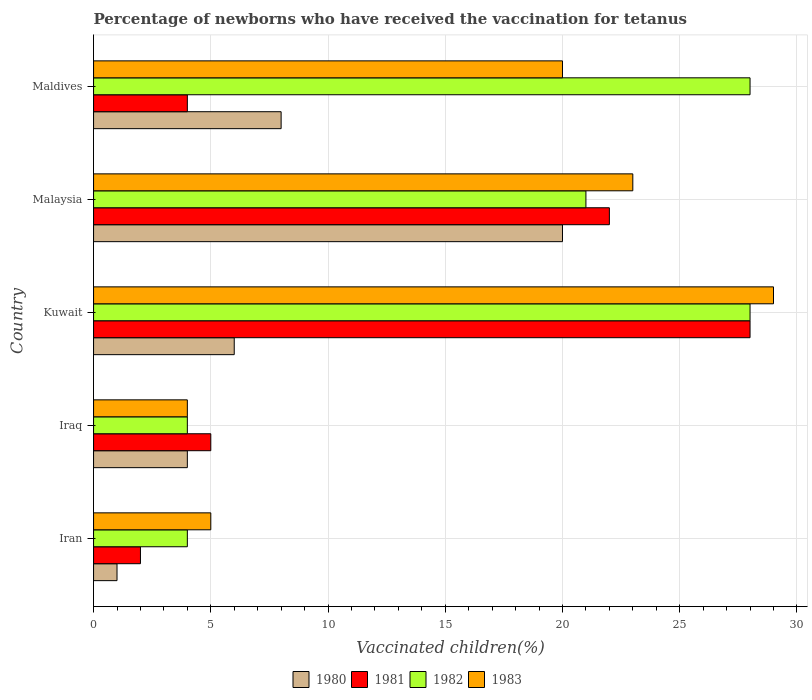How many bars are there on the 4th tick from the top?
Ensure brevity in your answer.  4. How many bars are there on the 4th tick from the bottom?
Ensure brevity in your answer.  4. What is the label of the 1st group of bars from the top?
Make the answer very short. Maldives. In how many cases, is the number of bars for a given country not equal to the number of legend labels?
Your answer should be very brief. 0. In which country was the percentage of vaccinated children in 1982 maximum?
Give a very brief answer. Kuwait. In which country was the percentage of vaccinated children in 1983 minimum?
Make the answer very short. Iraq. What is the difference between the percentage of vaccinated children in 1983 in Iran and that in Iraq?
Offer a very short reply. 1. What is the difference between the percentage of vaccinated children in 1982 in Iran and the percentage of vaccinated children in 1980 in Iraq?
Your answer should be compact. 0. What is the average percentage of vaccinated children in 1980 per country?
Provide a succinct answer. 7.8. In how many countries, is the percentage of vaccinated children in 1980 greater than 9 %?
Your answer should be very brief. 1. What is the ratio of the percentage of vaccinated children in 1982 in Iran to that in Kuwait?
Provide a short and direct response. 0.14. Is the difference between the percentage of vaccinated children in 1983 in Iraq and Maldives greater than the difference between the percentage of vaccinated children in 1982 in Iraq and Maldives?
Provide a short and direct response. Yes. What is the difference between the highest and the second highest percentage of vaccinated children in 1981?
Give a very brief answer. 6. What is the difference between the highest and the lowest percentage of vaccinated children in 1982?
Provide a short and direct response. 24. In how many countries, is the percentage of vaccinated children in 1983 greater than the average percentage of vaccinated children in 1983 taken over all countries?
Offer a terse response. 3. Is the sum of the percentage of vaccinated children in 1983 in Iran and Iraq greater than the maximum percentage of vaccinated children in 1980 across all countries?
Offer a terse response. No. What does the 3rd bar from the top in Malaysia represents?
Your answer should be compact. 1981. What does the 2nd bar from the bottom in Iran represents?
Offer a terse response. 1981. Is it the case that in every country, the sum of the percentage of vaccinated children in 1983 and percentage of vaccinated children in 1982 is greater than the percentage of vaccinated children in 1980?
Make the answer very short. Yes. How many bars are there?
Offer a very short reply. 20. Are all the bars in the graph horizontal?
Offer a terse response. Yes. Where does the legend appear in the graph?
Make the answer very short. Bottom center. How are the legend labels stacked?
Give a very brief answer. Horizontal. What is the title of the graph?
Your answer should be compact. Percentage of newborns who have received the vaccination for tetanus. What is the label or title of the X-axis?
Provide a succinct answer. Vaccinated children(%). What is the Vaccinated children(%) in 1980 in Iran?
Offer a very short reply. 1. What is the Vaccinated children(%) in 1980 in Iraq?
Your answer should be compact. 4. What is the Vaccinated children(%) in 1981 in Iraq?
Your response must be concise. 5. What is the Vaccinated children(%) of 1982 in Iraq?
Make the answer very short. 4. What is the Vaccinated children(%) of 1983 in Iraq?
Offer a very short reply. 4. What is the Vaccinated children(%) in 1980 in Kuwait?
Give a very brief answer. 6. What is the Vaccinated children(%) of 1981 in Kuwait?
Offer a very short reply. 28. What is the Vaccinated children(%) in 1983 in Kuwait?
Offer a terse response. 29. What is the Vaccinated children(%) in 1980 in Malaysia?
Your answer should be compact. 20. What is the Vaccinated children(%) in 1981 in Malaysia?
Provide a succinct answer. 22. What is the Vaccinated children(%) in 1983 in Malaysia?
Make the answer very short. 23. What is the Vaccinated children(%) in 1980 in Maldives?
Give a very brief answer. 8. What is the Vaccinated children(%) of 1983 in Maldives?
Ensure brevity in your answer.  20. Across all countries, what is the maximum Vaccinated children(%) in 1980?
Your response must be concise. 20. Across all countries, what is the minimum Vaccinated children(%) in 1982?
Ensure brevity in your answer.  4. What is the total Vaccinated children(%) of 1980 in the graph?
Your answer should be very brief. 39. What is the total Vaccinated children(%) of 1982 in the graph?
Ensure brevity in your answer.  85. What is the difference between the Vaccinated children(%) of 1980 in Iran and that in Iraq?
Your answer should be compact. -3. What is the difference between the Vaccinated children(%) in 1981 in Iran and that in Iraq?
Your answer should be very brief. -3. What is the difference between the Vaccinated children(%) in 1982 in Iran and that in Kuwait?
Keep it short and to the point. -24. What is the difference between the Vaccinated children(%) of 1983 in Iran and that in Malaysia?
Your answer should be very brief. -18. What is the difference between the Vaccinated children(%) in 1982 in Iraq and that in Kuwait?
Your response must be concise. -24. What is the difference between the Vaccinated children(%) in 1981 in Iraq and that in Malaysia?
Ensure brevity in your answer.  -17. What is the difference between the Vaccinated children(%) of 1982 in Iraq and that in Malaysia?
Your answer should be very brief. -17. What is the difference between the Vaccinated children(%) of 1983 in Iraq and that in Malaysia?
Offer a very short reply. -19. What is the difference between the Vaccinated children(%) of 1980 in Iraq and that in Maldives?
Your answer should be very brief. -4. What is the difference between the Vaccinated children(%) of 1981 in Iraq and that in Maldives?
Give a very brief answer. 1. What is the difference between the Vaccinated children(%) in 1982 in Iraq and that in Maldives?
Give a very brief answer. -24. What is the difference between the Vaccinated children(%) of 1980 in Kuwait and that in Malaysia?
Make the answer very short. -14. What is the difference between the Vaccinated children(%) in 1981 in Kuwait and that in Malaysia?
Offer a very short reply. 6. What is the difference between the Vaccinated children(%) of 1983 in Kuwait and that in Maldives?
Ensure brevity in your answer.  9. What is the difference between the Vaccinated children(%) of 1980 in Malaysia and that in Maldives?
Ensure brevity in your answer.  12. What is the difference between the Vaccinated children(%) in 1980 in Iran and the Vaccinated children(%) in 1982 in Iraq?
Your answer should be compact. -3. What is the difference between the Vaccinated children(%) of 1980 in Iran and the Vaccinated children(%) of 1983 in Iraq?
Give a very brief answer. -3. What is the difference between the Vaccinated children(%) in 1981 in Iran and the Vaccinated children(%) in 1983 in Iraq?
Ensure brevity in your answer.  -2. What is the difference between the Vaccinated children(%) of 1982 in Iran and the Vaccinated children(%) of 1983 in Iraq?
Provide a short and direct response. 0. What is the difference between the Vaccinated children(%) of 1980 in Iran and the Vaccinated children(%) of 1982 in Kuwait?
Give a very brief answer. -27. What is the difference between the Vaccinated children(%) of 1981 in Iran and the Vaccinated children(%) of 1983 in Kuwait?
Provide a succinct answer. -27. What is the difference between the Vaccinated children(%) of 1980 in Iran and the Vaccinated children(%) of 1981 in Maldives?
Provide a succinct answer. -3. What is the difference between the Vaccinated children(%) in 1980 in Iran and the Vaccinated children(%) in 1982 in Maldives?
Ensure brevity in your answer.  -27. What is the difference between the Vaccinated children(%) of 1980 in Iran and the Vaccinated children(%) of 1983 in Maldives?
Your answer should be compact. -19. What is the difference between the Vaccinated children(%) of 1981 in Iran and the Vaccinated children(%) of 1982 in Maldives?
Offer a terse response. -26. What is the difference between the Vaccinated children(%) of 1981 in Iran and the Vaccinated children(%) of 1983 in Maldives?
Provide a short and direct response. -18. What is the difference between the Vaccinated children(%) of 1982 in Iran and the Vaccinated children(%) of 1983 in Maldives?
Provide a succinct answer. -16. What is the difference between the Vaccinated children(%) in 1980 in Iraq and the Vaccinated children(%) in 1981 in Kuwait?
Offer a very short reply. -24. What is the difference between the Vaccinated children(%) in 1981 in Iraq and the Vaccinated children(%) in 1982 in Kuwait?
Keep it short and to the point. -23. What is the difference between the Vaccinated children(%) of 1980 in Iraq and the Vaccinated children(%) of 1982 in Malaysia?
Provide a succinct answer. -17. What is the difference between the Vaccinated children(%) of 1981 in Iraq and the Vaccinated children(%) of 1982 in Malaysia?
Your response must be concise. -16. What is the difference between the Vaccinated children(%) in 1982 in Iraq and the Vaccinated children(%) in 1983 in Malaysia?
Your answer should be very brief. -19. What is the difference between the Vaccinated children(%) of 1980 in Iraq and the Vaccinated children(%) of 1982 in Maldives?
Offer a terse response. -24. What is the difference between the Vaccinated children(%) of 1980 in Kuwait and the Vaccinated children(%) of 1981 in Malaysia?
Offer a very short reply. -16. What is the difference between the Vaccinated children(%) of 1980 in Kuwait and the Vaccinated children(%) of 1981 in Maldives?
Keep it short and to the point. 2. What is the difference between the Vaccinated children(%) in 1982 in Kuwait and the Vaccinated children(%) in 1983 in Maldives?
Ensure brevity in your answer.  8. What is the difference between the Vaccinated children(%) of 1980 in Malaysia and the Vaccinated children(%) of 1983 in Maldives?
Your answer should be compact. 0. What is the average Vaccinated children(%) in 1982 per country?
Your answer should be very brief. 17. What is the difference between the Vaccinated children(%) of 1980 and Vaccinated children(%) of 1983 in Iran?
Make the answer very short. -4. What is the difference between the Vaccinated children(%) in 1980 and Vaccinated children(%) in 1982 in Iraq?
Offer a terse response. 0. What is the difference between the Vaccinated children(%) of 1980 and Vaccinated children(%) of 1983 in Iraq?
Offer a very short reply. 0. What is the difference between the Vaccinated children(%) of 1981 and Vaccinated children(%) of 1983 in Iraq?
Offer a terse response. 1. What is the difference between the Vaccinated children(%) in 1982 and Vaccinated children(%) in 1983 in Iraq?
Give a very brief answer. 0. What is the difference between the Vaccinated children(%) of 1980 and Vaccinated children(%) of 1981 in Kuwait?
Ensure brevity in your answer.  -22. What is the difference between the Vaccinated children(%) of 1980 and Vaccinated children(%) of 1983 in Kuwait?
Your answer should be very brief. -23. What is the difference between the Vaccinated children(%) in 1981 and Vaccinated children(%) in 1982 in Kuwait?
Give a very brief answer. 0. What is the difference between the Vaccinated children(%) of 1980 and Vaccinated children(%) of 1983 in Malaysia?
Offer a terse response. -3. What is the difference between the Vaccinated children(%) in 1981 and Vaccinated children(%) in 1982 in Malaysia?
Give a very brief answer. 1. What is the difference between the Vaccinated children(%) in 1980 and Vaccinated children(%) in 1981 in Maldives?
Keep it short and to the point. 4. What is the difference between the Vaccinated children(%) of 1981 and Vaccinated children(%) of 1983 in Maldives?
Make the answer very short. -16. What is the difference between the Vaccinated children(%) of 1982 and Vaccinated children(%) of 1983 in Maldives?
Your answer should be very brief. 8. What is the ratio of the Vaccinated children(%) in 1980 in Iran to that in Iraq?
Provide a short and direct response. 0.25. What is the ratio of the Vaccinated children(%) of 1983 in Iran to that in Iraq?
Your answer should be compact. 1.25. What is the ratio of the Vaccinated children(%) in 1980 in Iran to that in Kuwait?
Give a very brief answer. 0.17. What is the ratio of the Vaccinated children(%) of 1981 in Iran to that in Kuwait?
Your response must be concise. 0.07. What is the ratio of the Vaccinated children(%) in 1982 in Iran to that in Kuwait?
Provide a short and direct response. 0.14. What is the ratio of the Vaccinated children(%) in 1983 in Iran to that in Kuwait?
Provide a short and direct response. 0.17. What is the ratio of the Vaccinated children(%) of 1980 in Iran to that in Malaysia?
Make the answer very short. 0.05. What is the ratio of the Vaccinated children(%) in 1981 in Iran to that in Malaysia?
Provide a succinct answer. 0.09. What is the ratio of the Vaccinated children(%) of 1982 in Iran to that in Malaysia?
Provide a succinct answer. 0.19. What is the ratio of the Vaccinated children(%) in 1983 in Iran to that in Malaysia?
Give a very brief answer. 0.22. What is the ratio of the Vaccinated children(%) of 1981 in Iran to that in Maldives?
Offer a terse response. 0.5. What is the ratio of the Vaccinated children(%) in 1982 in Iran to that in Maldives?
Your response must be concise. 0.14. What is the ratio of the Vaccinated children(%) in 1983 in Iran to that in Maldives?
Provide a succinct answer. 0.25. What is the ratio of the Vaccinated children(%) of 1981 in Iraq to that in Kuwait?
Offer a very short reply. 0.18. What is the ratio of the Vaccinated children(%) of 1982 in Iraq to that in Kuwait?
Keep it short and to the point. 0.14. What is the ratio of the Vaccinated children(%) of 1983 in Iraq to that in Kuwait?
Provide a succinct answer. 0.14. What is the ratio of the Vaccinated children(%) of 1981 in Iraq to that in Malaysia?
Your answer should be very brief. 0.23. What is the ratio of the Vaccinated children(%) of 1982 in Iraq to that in Malaysia?
Give a very brief answer. 0.19. What is the ratio of the Vaccinated children(%) in 1983 in Iraq to that in Malaysia?
Provide a succinct answer. 0.17. What is the ratio of the Vaccinated children(%) in 1980 in Iraq to that in Maldives?
Ensure brevity in your answer.  0.5. What is the ratio of the Vaccinated children(%) in 1982 in Iraq to that in Maldives?
Offer a very short reply. 0.14. What is the ratio of the Vaccinated children(%) in 1983 in Iraq to that in Maldives?
Keep it short and to the point. 0.2. What is the ratio of the Vaccinated children(%) in 1980 in Kuwait to that in Malaysia?
Keep it short and to the point. 0.3. What is the ratio of the Vaccinated children(%) of 1981 in Kuwait to that in Malaysia?
Your response must be concise. 1.27. What is the ratio of the Vaccinated children(%) in 1983 in Kuwait to that in Malaysia?
Offer a terse response. 1.26. What is the ratio of the Vaccinated children(%) of 1982 in Kuwait to that in Maldives?
Offer a terse response. 1. What is the ratio of the Vaccinated children(%) of 1983 in Kuwait to that in Maldives?
Your answer should be very brief. 1.45. What is the ratio of the Vaccinated children(%) in 1980 in Malaysia to that in Maldives?
Your response must be concise. 2.5. What is the ratio of the Vaccinated children(%) in 1981 in Malaysia to that in Maldives?
Keep it short and to the point. 5.5. What is the ratio of the Vaccinated children(%) in 1983 in Malaysia to that in Maldives?
Provide a succinct answer. 1.15. What is the difference between the highest and the second highest Vaccinated children(%) in 1981?
Your response must be concise. 6. What is the difference between the highest and the second highest Vaccinated children(%) in 1982?
Your response must be concise. 0. What is the difference between the highest and the second highest Vaccinated children(%) of 1983?
Make the answer very short. 6. What is the difference between the highest and the lowest Vaccinated children(%) of 1980?
Your response must be concise. 19. What is the difference between the highest and the lowest Vaccinated children(%) of 1982?
Provide a succinct answer. 24. What is the difference between the highest and the lowest Vaccinated children(%) in 1983?
Offer a terse response. 25. 